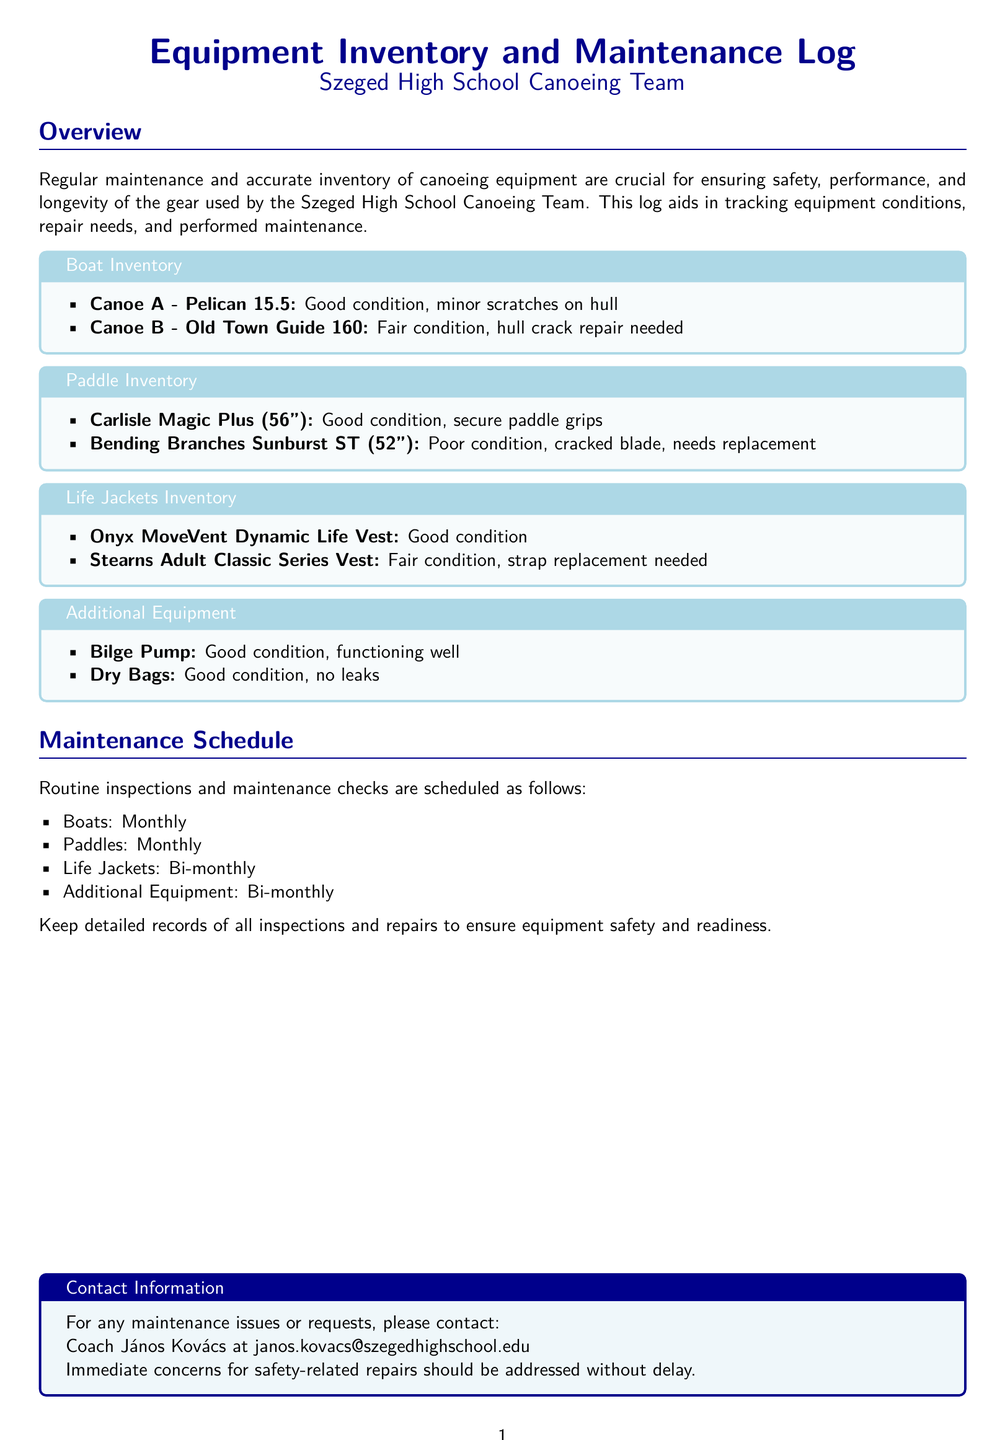What is the condition of Canoe A? The condition of Canoe A is listed under the Boat Inventory section of the document, indicating it is in good condition with minor scratches.
Answer: Good condition What repair is needed for Canoe B? The document states that Canoe B requires a hull crack repair and is noted under the Boat Inventory section.
Answer: Hull crack repair How many paddles are in poor condition? The paddle conditions are outlined in the Paddle Inventory section, where one paddle is specifically noted as being in poor condition.
Answer: One When are routine inspections for boats scheduled? The Maintenance Schedule section specifies that routine inspections for boats are performed monthly.
Answer: Monthly Which life jacket needs a strap replacement? The Life Jackets Inventory section identifies the Stearns Adult Classic Series Vest as needing a strap replacement due to its fair condition.
Answer: Stearns Adult Classic Series Vest What is the condition of the Bending Branches paddle? The Paddle Inventory indicates that the Bending Branches Sunburst ST paddle is in poor condition and has a cracked blade.
Answer: Poor condition How often are additional equipment inspections conducted? According to the Maintenance Schedule, inspections for additional equipment are conducted bi-monthly.
Answer: Bi-monthly Who should be contacted for maintenance issues? The Contact Information box provides the name of the coach to be contacted for maintenance issues.
Answer: Coach János Kovács 